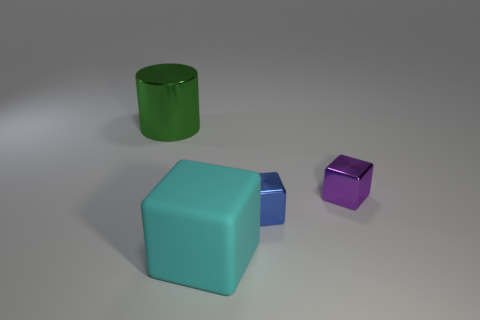Add 1 large green things. How many objects exist? 5 Subtract all blocks. How many objects are left? 1 Add 1 small blue metal things. How many small blue metal things are left? 2 Add 4 blue blocks. How many blue blocks exist? 5 Subtract 1 blue blocks. How many objects are left? 3 Subtract all big brown spheres. Subtract all purple cubes. How many objects are left? 3 